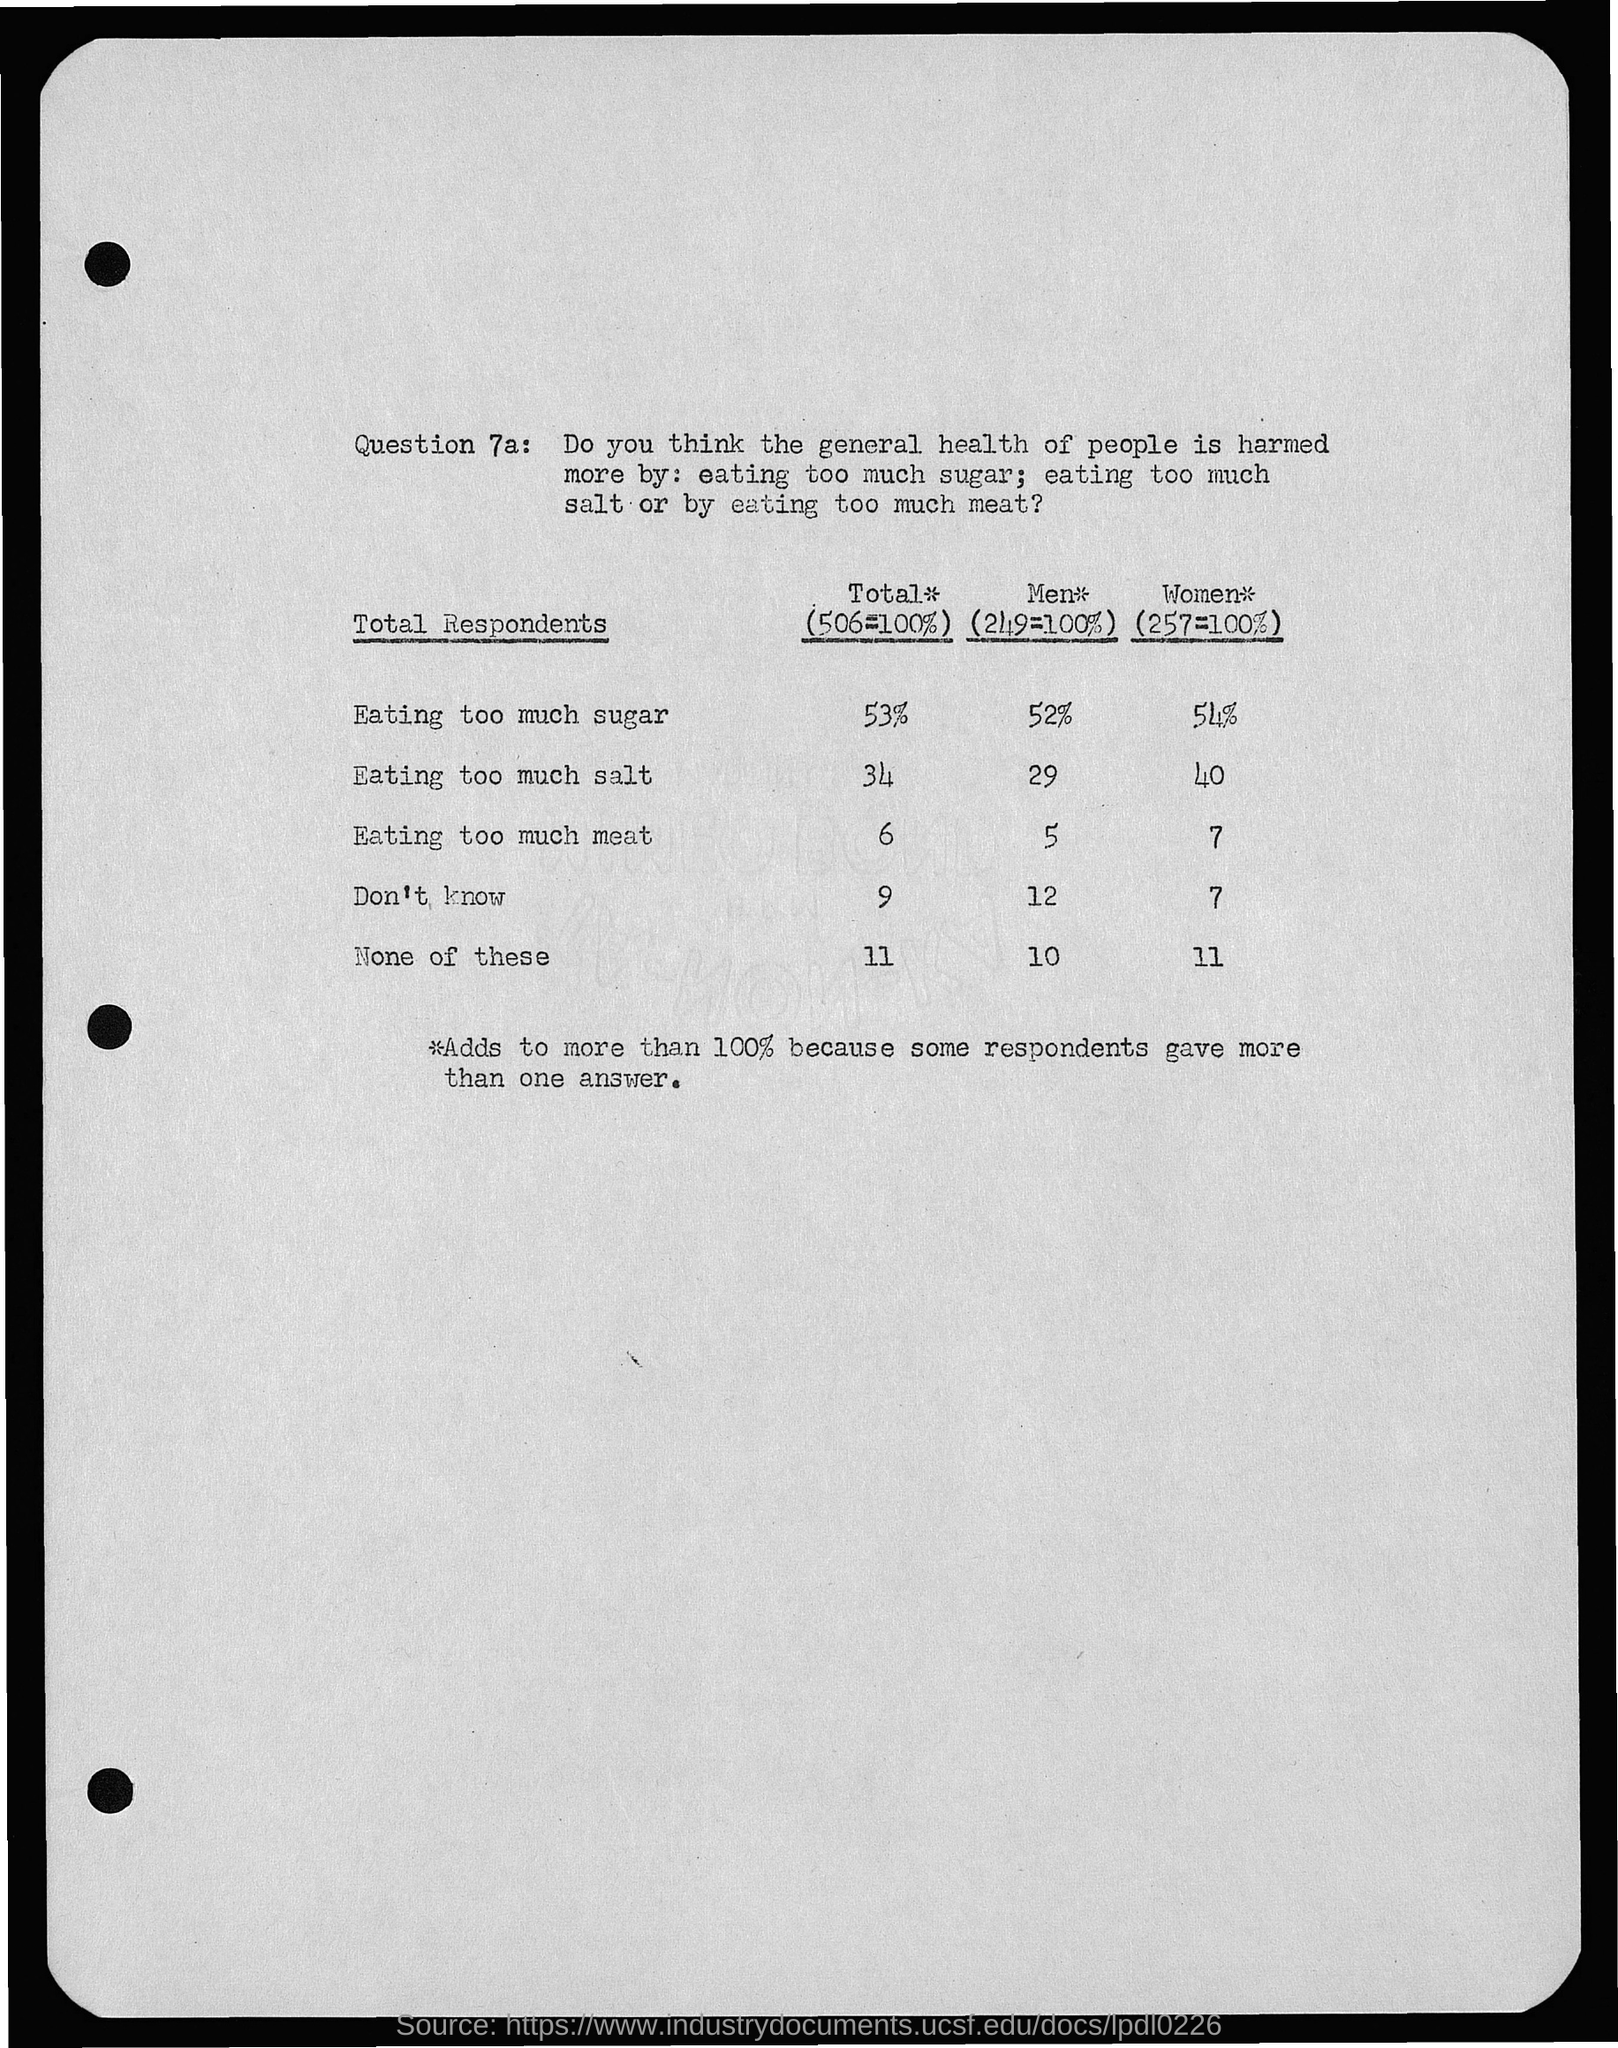What is the percentage of eating too much sugar in women? The statistics from the survey indicate that 54% of women believe that the general health of people is harmed more by eating too much sugar, compared to other dietary concerns such as eating too much salt or meat. 